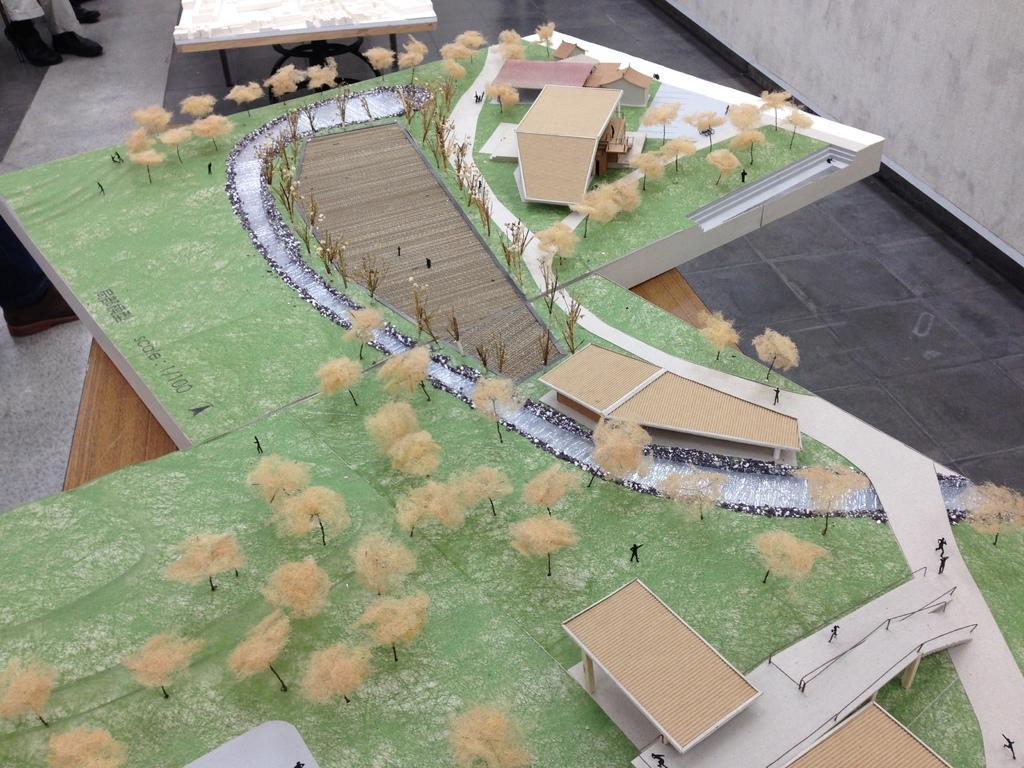How would you summarize this image in a sentence or two? In this image I see a miniature on the cardboard and I see the trees, houses, few people, green grass and the path and I see the floor over here and this thing is on a table and I see the humans legs over here and I see the wall over here. 